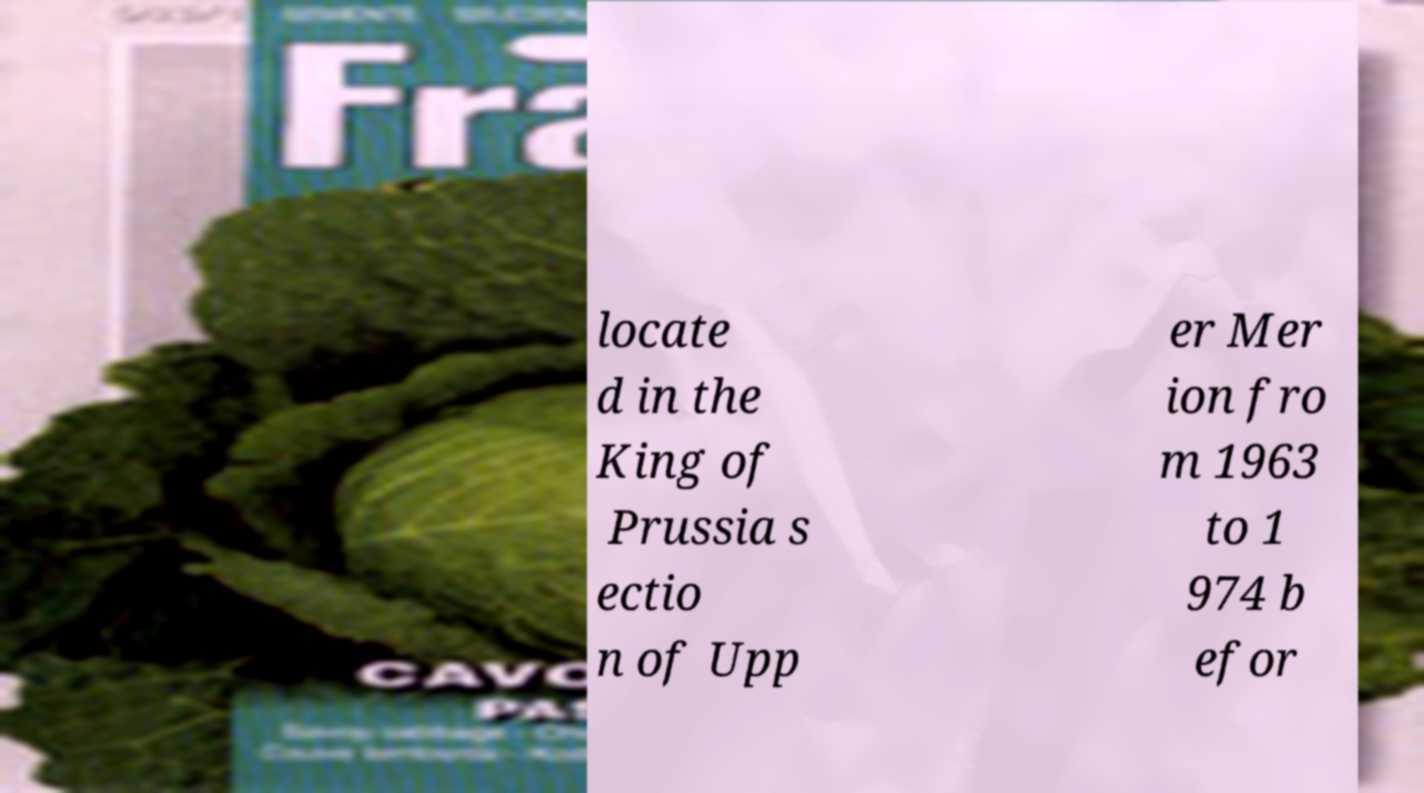Could you extract and type out the text from this image? locate d in the King of Prussia s ectio n of Upp er Mer ion fro m 1963 to 1 974 b efor 